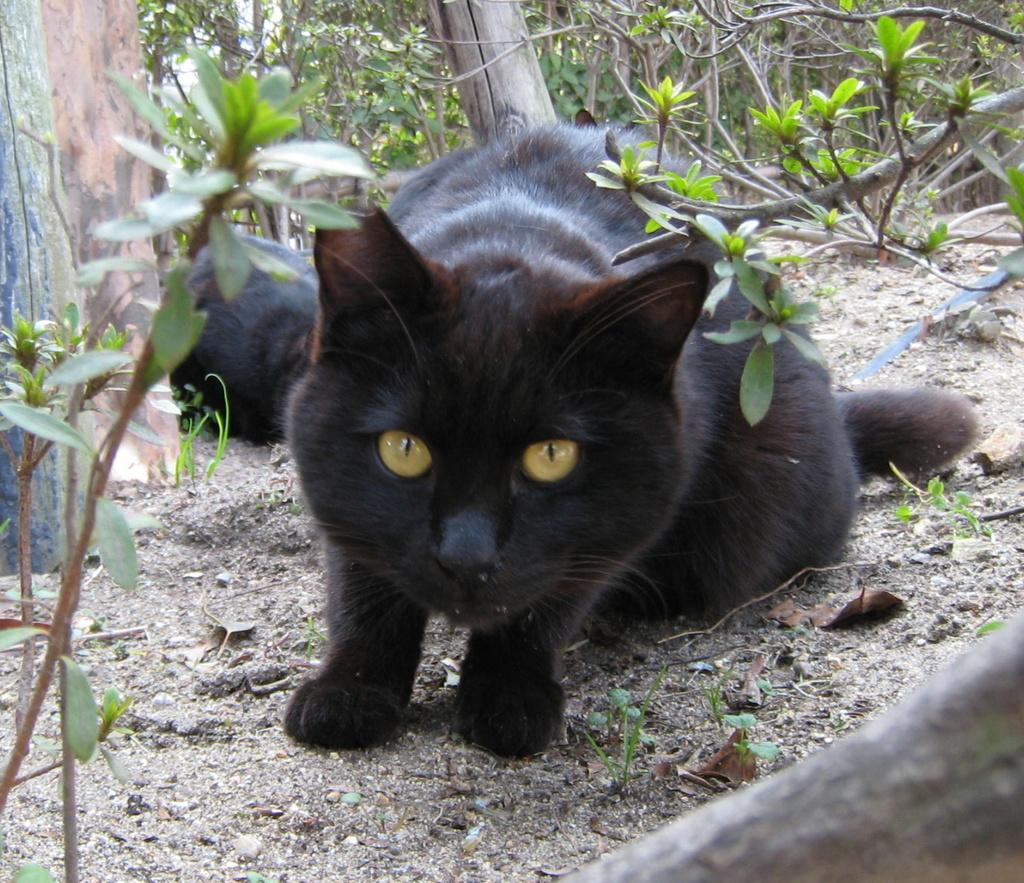What type of animal is in the image? There is a black color cat in the image. What can be seen in the background of the image? There are plants in the background of the image. What is located at the bottom of the image? Stones are present at the bottom of the image. Can you see a robin wearing a crown in the image? There is no robin or crown present in the image. Is there a rifle visible in the image? There is no rifle present in the image. 